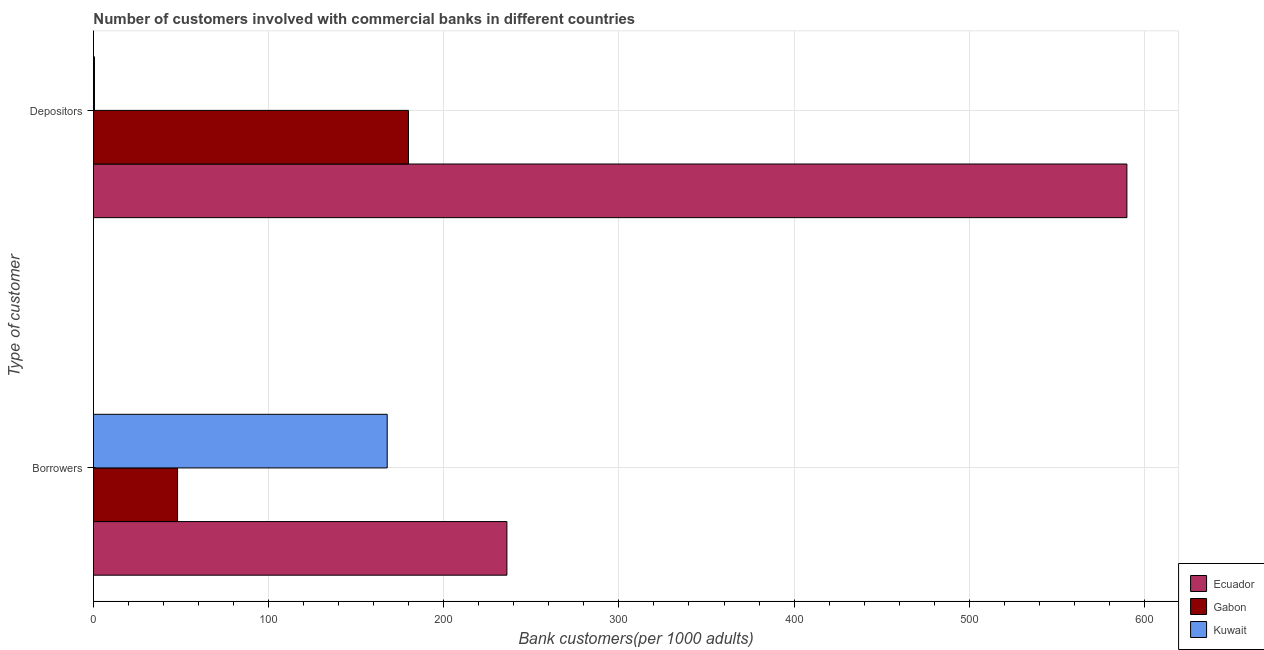How many groups of bars are there?
Provide a short and direct response. 2. Are the number of bars per tick equal to the number of legend labels?
Keep it short and to the point. Yes. Are the number of bars on each tick of the Y-axis equal?
Make the answer very short. Yes. How many bars are there on the 1st tick from the top?
Your answer should be compact. 3. What is the label of the 1st group of bars from the top?
Provide a short and direct response. Depositors. What is the number of borrowers in Ecuador?
Offer a terse response. 236.05. Across all countries, what is the maximum number of depositors?
Your answer should be very brief. 590.02. Across all countries, what is the minimum number of depositors?
Offer a terse response. 0.59. In which country was the number of depositors maximum?
Your response must be concise. Ecuador. In which country was the number of depositors minimum?
Keep it short and to the point. Kuwait. What is the total number of depositors in the graph?
Ensure brevity in your answer.  770.45. What is the difference between the number of borrowers in Gabon and that in Kuwait?
Make the answer very short. -119.7. What is the difference between the number of depositors in Ecuador and the number of borrowers in Gabon?
Ensure brevity in your answer.  542. What is the average number of depositors per country?
Your response must be concise. 256.82. What is the difference between the number of depositors and number of borrowers in Gabon?
Provide a short and direct response. 131.82. What is the ratio of the number of depositors in Gabon to that in Ecuador?
Make the answer very short. 0.3. What does the 1st bar from the top in Depositors represents?
Ensure brevity in your answer.  Kuwait. What does the 2nd bar from the bottom in Depositors represents?
Provide a short and direct response. Gabon. How many bars are there?
Your response must be concise. 6. Are the values on the major ticks of X-axis written in scientific E-notation?
Offer a very short reply. No. Where does the legend appear in the graph?
Offer a very short reply. Bottom right. How many legend labels are there?
Provide a short and direct response. 3. What is the title of the graph?
Offer a terse response. Number of customers involved with commercial banks in different countries. What is the label or title of the X-axis?
Give a very brief answer. Bank customers(per 1000 adults). What is the label or title of the Y-axis?
Your answer should be compact. Type of customer. What is the Bank customers(per 1000 adults) of Ecuador in Borrowers?
Your answer should be very brief. 236.05. What is the Bank customers(per 1000 adults) of Gabon in Borrowers?
Provide a succinct answer. 48.02. What is the Bank customers(per 1000 adults) of Kuwait in Borrowers?
Ensure brevity in your answer.  167.71. What is the Bank customers(per 1000 adults) of Ecuador in Depositors?
Your answer should be compact. 590.02. What is the Bank customers(per 1000 adults) in Gabon in Depositors?
Your answer should be very brief. 179.84. What is the Bank customers(per 1000 adults) in Kuwait in Depositors?
Provide a succinct answer. 0.59. Across all Type of customer, what is the maximum Bank customers(per 1000 adults) in Ecuador?
Your answer should be very brief. 590.02. Across all Type of customer, what is the maximum Bank customers(per 1000 adults) of Gabon?
Your response must be concise. 179.84. Across all Type of customer, what is the maximum Bank customers(per 1000 adults) in Kuwait?
Give a very brief answer. 167.71. Across all Type of customer, what is the minimum Bank customers(per 1000 adults) of Ecuador?
Provide a succinct answer. 236.05. Across all Type of customer, what is the minimum Bank customers(per 1000 adults) in Gabon?
Your answer should be very brief. 48.02. Across all Type of customer, what is the minimum Bank customers(per 1000 adults) in Kuwait?
Give a very brief answer. 0.59. What is the total Bank customers(per 1000 adults) of Ecuador in the graph?
Make the answer very short. 826.07. What is the total Bank customers(per 1000 adults) in Gabon in the graph?
Your response must be concise. 227.86. What is the total Bank customers(per 1000 adults) of Kuwait in the graph?
Make the answer very short. 168.3. What is the difference between the Bank customers(per 1000 adults) in Ecuador in Borrowers and that in Depositors?
Provide a short and direct response. -353.97. What is the difference between the Bank customers(per 1000 adults) in Gabon in Borrowers and that in Depositors?
Provide a succinct answer. -131.82. What is the difference between the Bank customers(per 1000 adults) of Kuwait in Borrowers and that in Depositors?
Provide a short and direct response. 167.13. What is the difference between the Bank customers(per 1000 adults) in Ecuador in Borrowers and the Bank customers(per 1000 adults) in Gabon in Depositors?
Make the answer very short. 56.21. What is the difference between the Bank customers(per 1000 adults) of Ecuador in Borrowers and the Bank customers(per 1000 adults) of Kuwait in Depositors?
Offer a terse response. 235.47. What is the difference between the Bank customers(per 1000 adults) in Gabon in Borrowers and the Bank customers(per 1000 adults) in Kuwait in Depositors?
Provide a short and direct response. 47.43. What is the average Bank customers(per 1000 adults) of Ecuador per Type of customer?
Make the answer very short. 413.04. What is the average Bank customers(per 1000 adults) in Gabon per Type of customer?
Your answer should be compact. 113.93. What is the average Bank customers(per 1000 adults) in Kuwait per Type of customer?
Your response must be concise. 84.15. What is the difference between the Bank customers(per 1000 adults) in Ecuador and Bank customers(per 1000 adults) in Gabon in Borrowers?
Keep it short and to the point. 188.03. What is the difference between the Bank customers(per 1000 adults) of Ecuador and Bank customers(per 1000 adults) of Kuwait in Borrowers?
Ensure brevity in your answer.  68.34. What is the difference between the Bank customers(per 1000 adults) of Gabon and Bank customers(per 1000 adults) of Kuwait in Borrowers?
Provide a short and direct response. -119.7. What is the difference between the Bank customers(per 1000 adults) in Ecuador and Bank customers(per 1000 adults) in Gabon in Depositors?
Your answer should be very brief. 410.18. What is the difference between the Bank customers(per 1000 adults) of Ecuador and Bank customers(per 1000 adults) of Kuwait in Depositors?
Make the answer very short. 589.44. What is the difference between the Bank customers(per 1000 adults) of Gabon and Bank customers(per 1000 adults) of Kuwait in Depositors?
Provide a succinct answer. 179.26. What is the ratio of the Bank customers(per 1000 adults) in Ecuador in Borrowers to that in Depositors?
Ensure brevity in your answer.  0.4. What is the ratio of the Bank customers(per 1000 adults) of Gabon in Borrowers to that in Depositors?
Provide a short and direct response. 0.27. What is the ratio of the Bank customers(per 1000 adults) in Kuwait in Borrowers to that in Depositors?
Give a very brief answer. 286.68. What is the difference between the highest and the second highest Bank customers(per 1000 adults) of Ecuador?
Make the answer very short. 353.97. What is the difference between the highest and the second highest Bank customers(per 1000 adults) in Gabon?
Your answer should be compact. 131.82. What is the difference between the highest and the second highest Bank customers(per 1000 adults) in Kuwait?
Your answer should be compact. 167.13. What is the difference between the highest and the lowest Bank customers(per 1000 adults) of Ecuador?
Provide a short and direct response. 353.97. What is the difference between the highest and the lowest Bank customers(per 1000 adults) in Gabon?
Offer a terse response. 131.82. What is the difference between the highest and the lowest Bank customers(per 1000 adults) in Kuwait?
Provide a succinct answer. 167.13. 